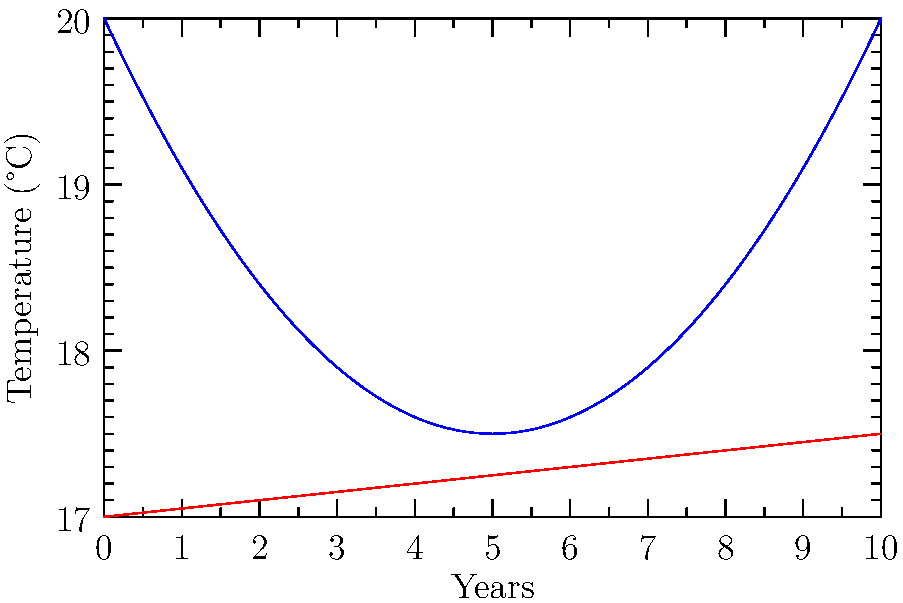The graph shows local temperature measurements (blue) and a climate model prediction (red) over 10 years. Based on your personal experience with local weather, which conclusion about climate change seems more reliable? Step 1: Observe the local temperature curve (blue). It shows more variation and fluctuations, which aligns with our day-to-day experience of weather changes.

Step 2: Look at the climate model prediction (red). It shows a steady, gradual increase over time, which doesn't match our immediate perceptions of temperature changes.

Step 3: Consider that personal experience is limited to a specific location and short time frame, while climate change occurs on a global scale over decades.

Step 4: Recognize that the local temperature curve, despite its variations, shows an overall increasing trend, which actually supports the climate model prediction.

Step 5: Understand that scientific models are based on vast amounts of data from many locations over long periods, not just personal observations.

Step 6: Conclude that while personal experience feels more relatable, it's not sufficient to draw conclusions about long-term, global climate trends. The climate model, despite seeming less connected to our daily life, provides a more reliable indication of overall climate change.
Answer: Climate model prediction is more reliable for assessing long-term climate change. 